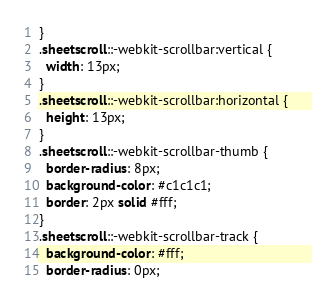<code> <loc_0><loc_0><loc_500><loc_500><_CSS_>}
.sheetscroll::-webkit-scrollbar:vertical {
  width: 13px;
}
.sheetscroll::-webkit-scrollbar:horizontal {
  height: 13px;
}
.sheetscroll::-webkit-scrollbar-thumb {
  border-radius: 8px;
  background-color: #c1c1c1;
  border: 2px solid #fff;
}
.sheetscroll::-webkit-scrollbar-track {
  background-color: #fff;
  border-radius: 0px;</code> 